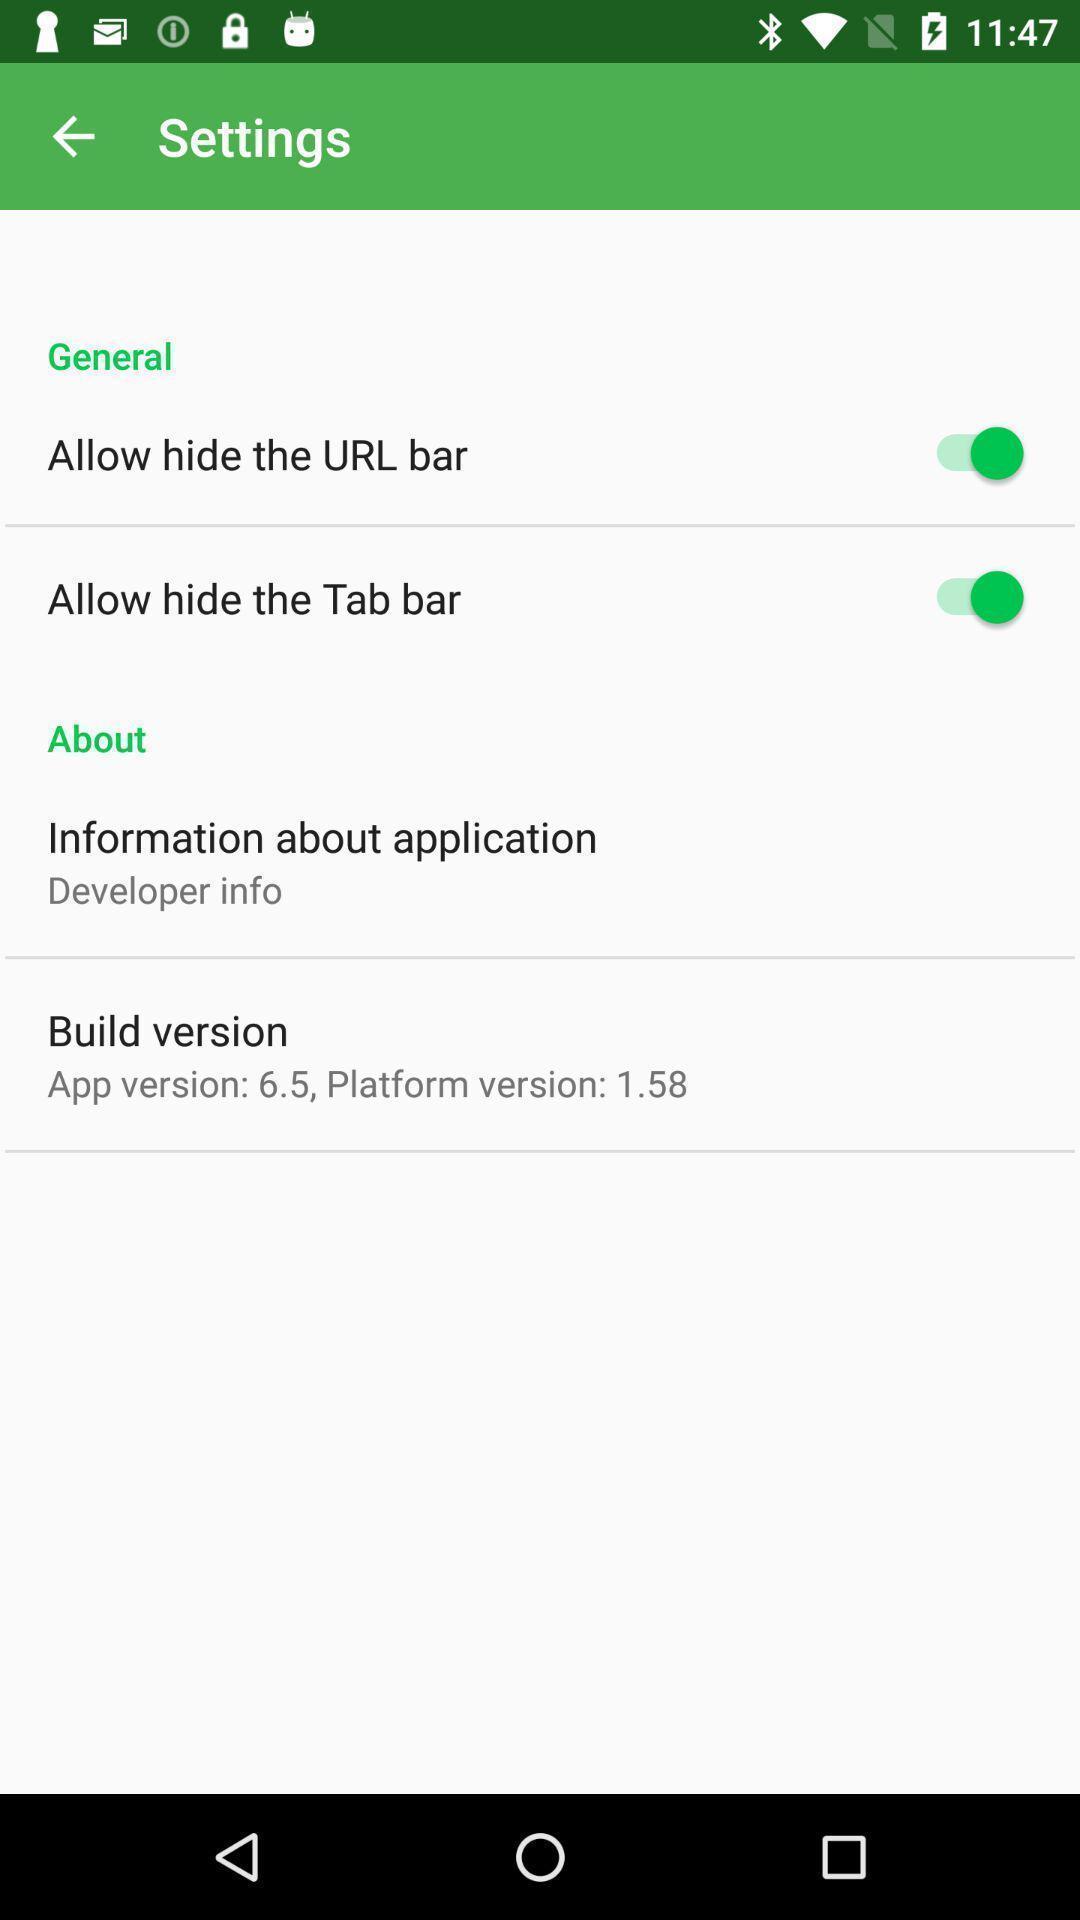Describe the visual elements of this screenshot. Page showing list of options in settings. 